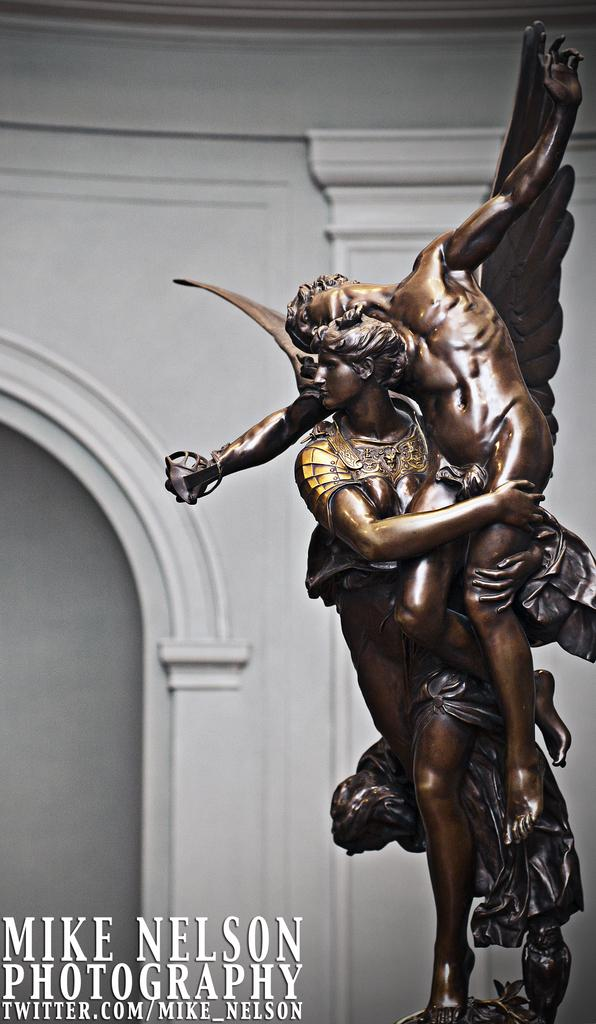What is the main subject in the image? There is a statue in the image. What can be seen in the background of the image? There is a wall in the background of the image. Is there any text present in the image? Yes, there is text at the bottom of the image. How many chickens are sitting on the statue in the image? There are no chickens present in the image; it features a statue without any chickens. What type of comfort can be seen provided by the statue in the image? The statue does not provide any comfort, as it is an inanimate object. 